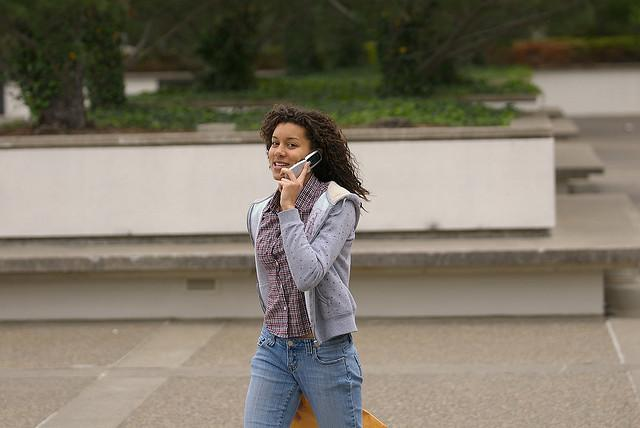How would she close the front of her sweater? Please explain your reasoning. zipper. The front of her sweater is visible and has a zipper on the edge. zippers are used for fastening so a garment with a zipper in this placement on either side would be fastened by the zipper. 